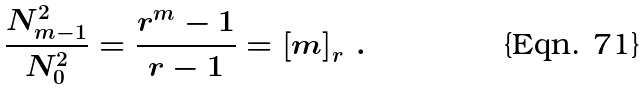Convert formula to latex. <formula><loc_0><loc_0><loc_500><loc_500>\frac { N _ { m - 1 } ^ { 2 } } { N _ { 0 } ^ { 2 } } = \frac { r ^ { m } - 1 } { r - 1 } = \left [ m \right ] _ { r } \, .</formula> 